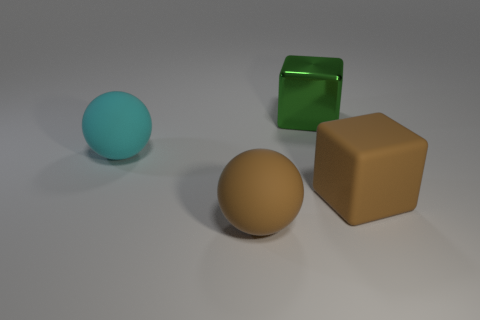Add 2 large green metal blocks. How many objects exist? 6 Add 1 large brown rubber cubes. How many large brown rubber cubes exist? 2 Subtract 0 blue blocks. How many objects are left? 4 Subtract all big objects. Subtract all small blue cylinders. How many objects are left? 0 Add 2 large brown cubes. How many large brown cubes are left? 3 